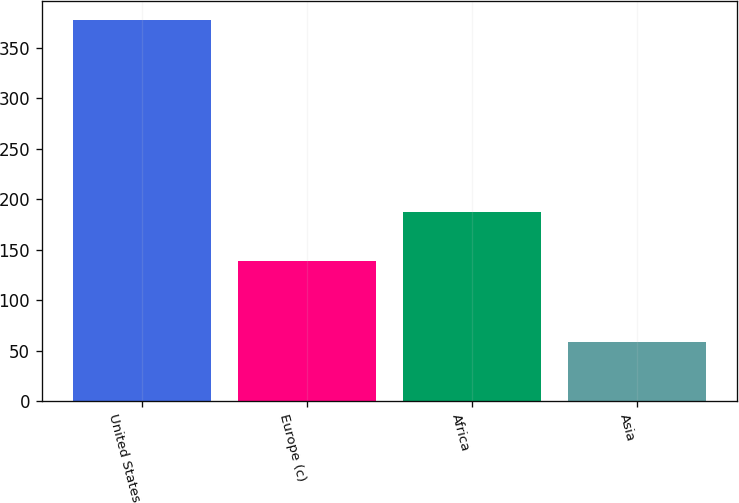<chart> <loc_0><loc_0><loc_500><loc_500><bar_chart><fcel>United States<fcel>Europe (c)<fcel>Africa<fcel>Asia<nl><fcel>378<fcel>139<fcel>187<fcel>58<nl></chart> 